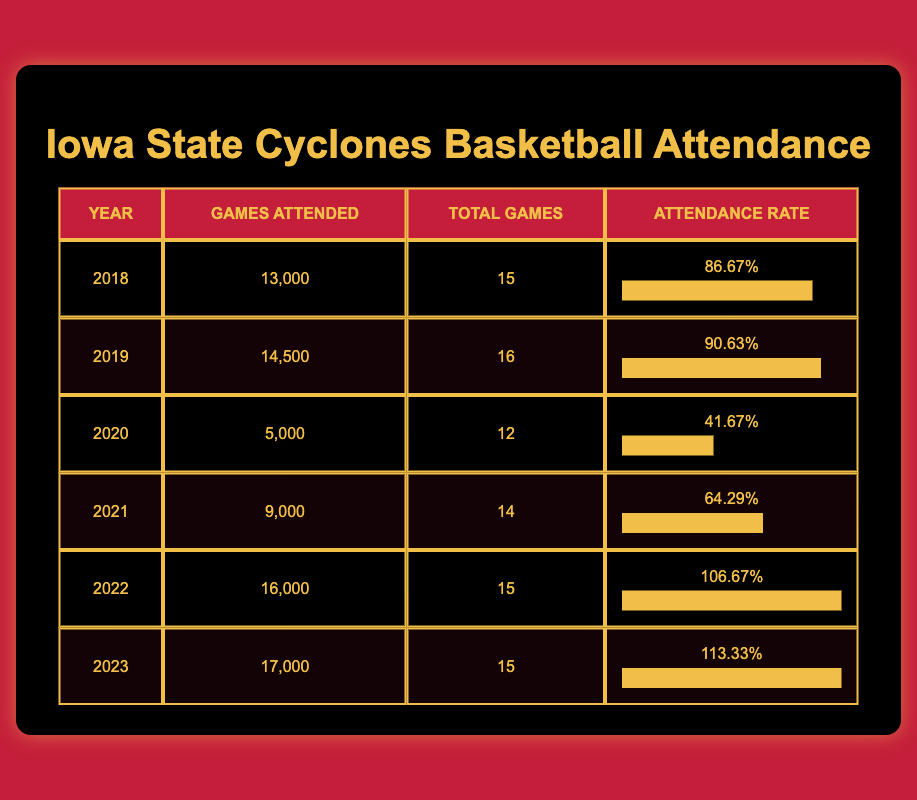What was the highest attendance recorded for Iowa State Cyclones basketball games? The table shows the games attended for each year, and the highest value is 17,000 in the year 2023.
Answer: 17,000 In which year did Iowa State Cyclones have the lowest attendance? The lowest attendance is shown in the table as 5,000 in the year 2020.
Answer: 5,000 What is the average attendance rate for the years 2018 to 2022? To find the average attendance rate, sum up the attendance rates for those years: (86.67% + 90.63% + 41.67% + 64.29% + 106.67%) / 5 = 78.19%.
Answer: 78.19% Did the attendance increase from 2021 to 2022? The attendance in 2021 was 9,000 and in 2022 was 16,000, which indicates an increase of 7,000. Therefore, yes, it increased.
Answer: Yes What is the total number of games attended from 2018 to 2023? To find the total, sum the games attended from each year: 13,000 + 14,500 + 5,000 + 9,000 + 16,000 + 17,000 = 74,500.
Answer: 74,500 In which year did the Iowa State Cyclones have an attendance rate above 100%? The attendance rate above 100% occurred in both 2022 and 2023 with rates of 106.67% and 113.33%, respectively.
Answer: 2022 and 2023 What is the difference in games attended between 2019 and 2023? The difference is calculated by subtracting the games attended in 2019 (14,500) from 2023 (17,000): 17,000 - 14,500 = 2,500.
Answer: 2,500 Was the attendance in 2020 higher than the attendance in 2018? The attendance in 2020 (5,000) was lower than the attendance in 2018 (13,000), so the statement is false.
Answer: No What has been the trend in attendance from 2018 to 2023? The attendance shows a general upward trend from 2018 (13,000) to 2023 (17,000), with a significant drop in 2020, but recovery in subsequent years.
Answer: Upward trend 